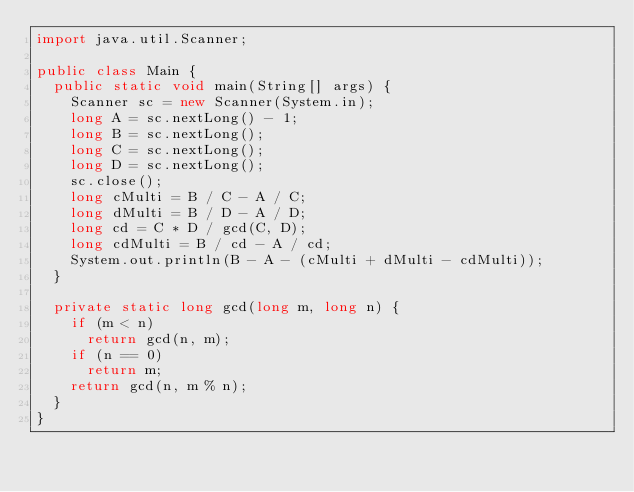Convert code to text. <code><loc_0><loc_0><loc_500><loc_500><_Java_>import java.util.Scanner;

public class Main {
	public static void main(String[] args) {
		Scanner sc = new Scanner(System.in);
		long A = sc.nextLong() - 1;
		long B = sc.nextLong();
		long C = sc.nextLong();
		long D = sc.nextLong();
		sc.close();
		long cMulti = B / C - A / C;
		long dMulti = B / D - A / D;
		long cd = C * D / gcd(C, D);
		long cdMulti = B / cd - A / cd;
		System.out.println(B - A - (cMulti + dMulti - cdMulti));
	}

	private static long gcd(long m, long n) {
		if (m < n)
			return gcd(n, m);
		if (n == 0)
			return m;
		return gcd(n, m % n);
	}
}</code> 